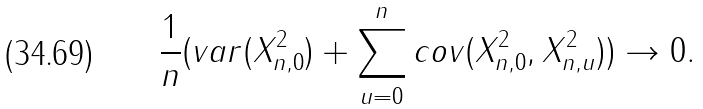<formula> <loc_0><loc_0><loc_500><loc_500>\frac { 1 } { n } ( v a r ( X _ { n , 0 } ^ { 2 } ) + \sum _ { u = 0 } ^ { n } c o v ( X _ { n , 0 } ^ { 2 } , X _ { n , u } ^ { 2 } ) ) \rightarrow 0 .</formula> 